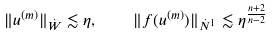Convert formula to latex. <formula><loc_0><loc_0><loc_500><loc_500>\| u ^ { ( m ) } \| _ { \dot { W } } \lesssim \eta , \quad \| f ( u ^ { ( m ) } ) \| _ { \dot { N } ^ { 1 } } \lesssim \eta ^ { \frac { n + 2 } { n - 2 } }</formula> 